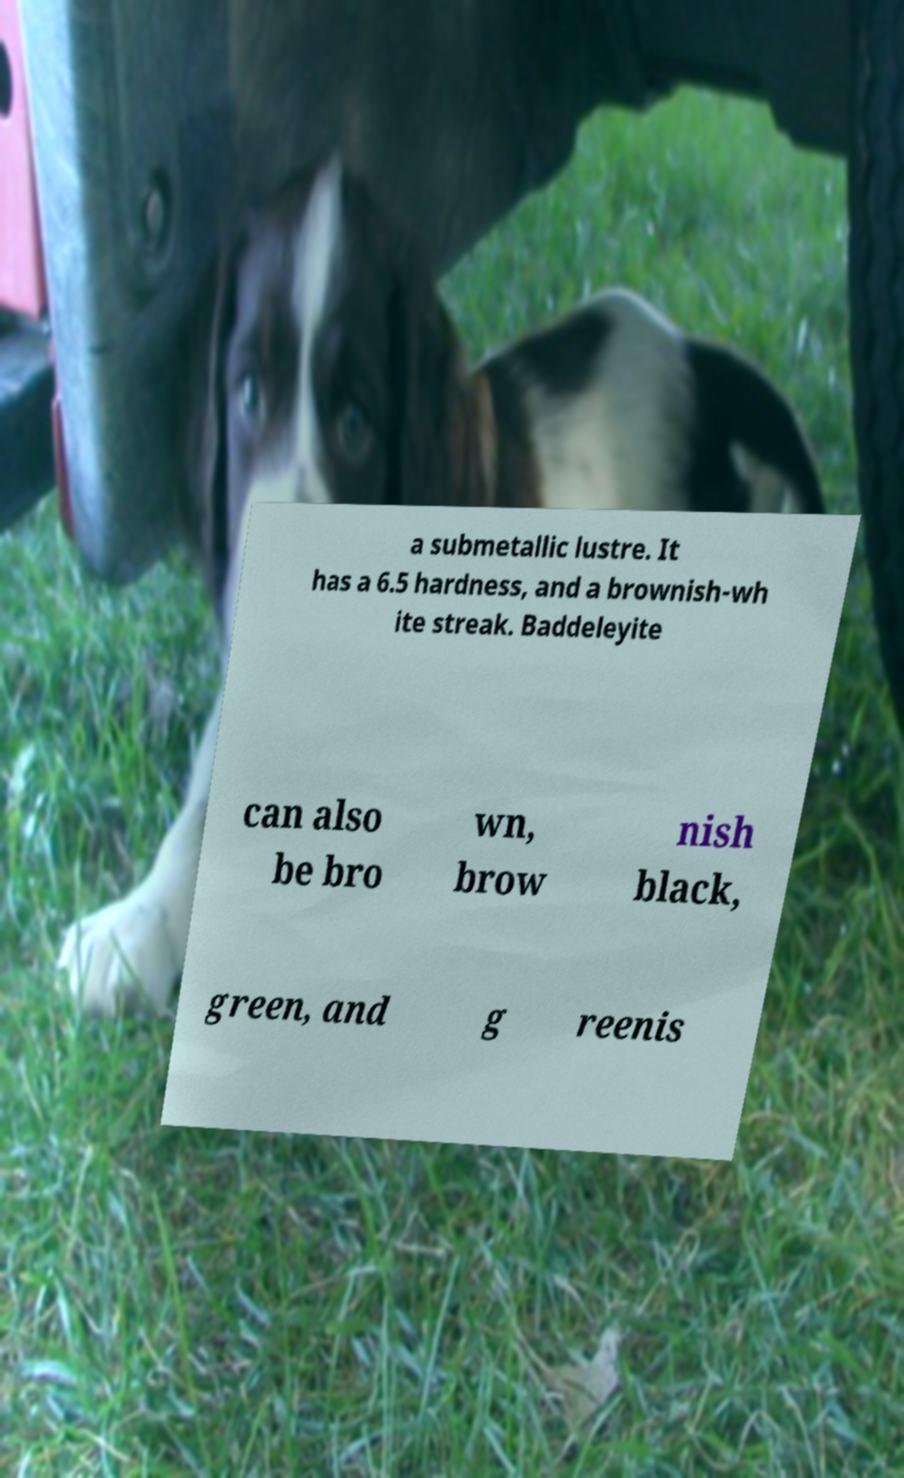Please identify and transcribe the text found in this image. a submetallic lustre. It has a 6.5 hardness, and a brownish-wh ite streak. Baddeleyite can also be bro wn, brow nish black, green, and g reenis 